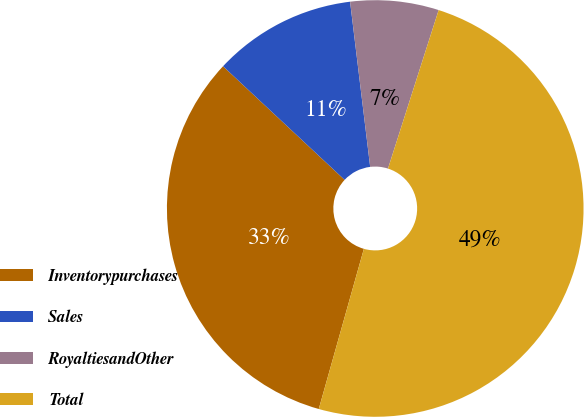Convert chart to OTSL. <chart><loc_0><loc_0><loc_500><loc_500><pie_chart><fcel>Inventorypurchases<fcel>Sales<fcel>RoyaltiesandOther<fcel>Total<nl><fcel>32.59%<fcel>11.11%<fcel>6.85%<fcel>49.44%<nl></chart> 